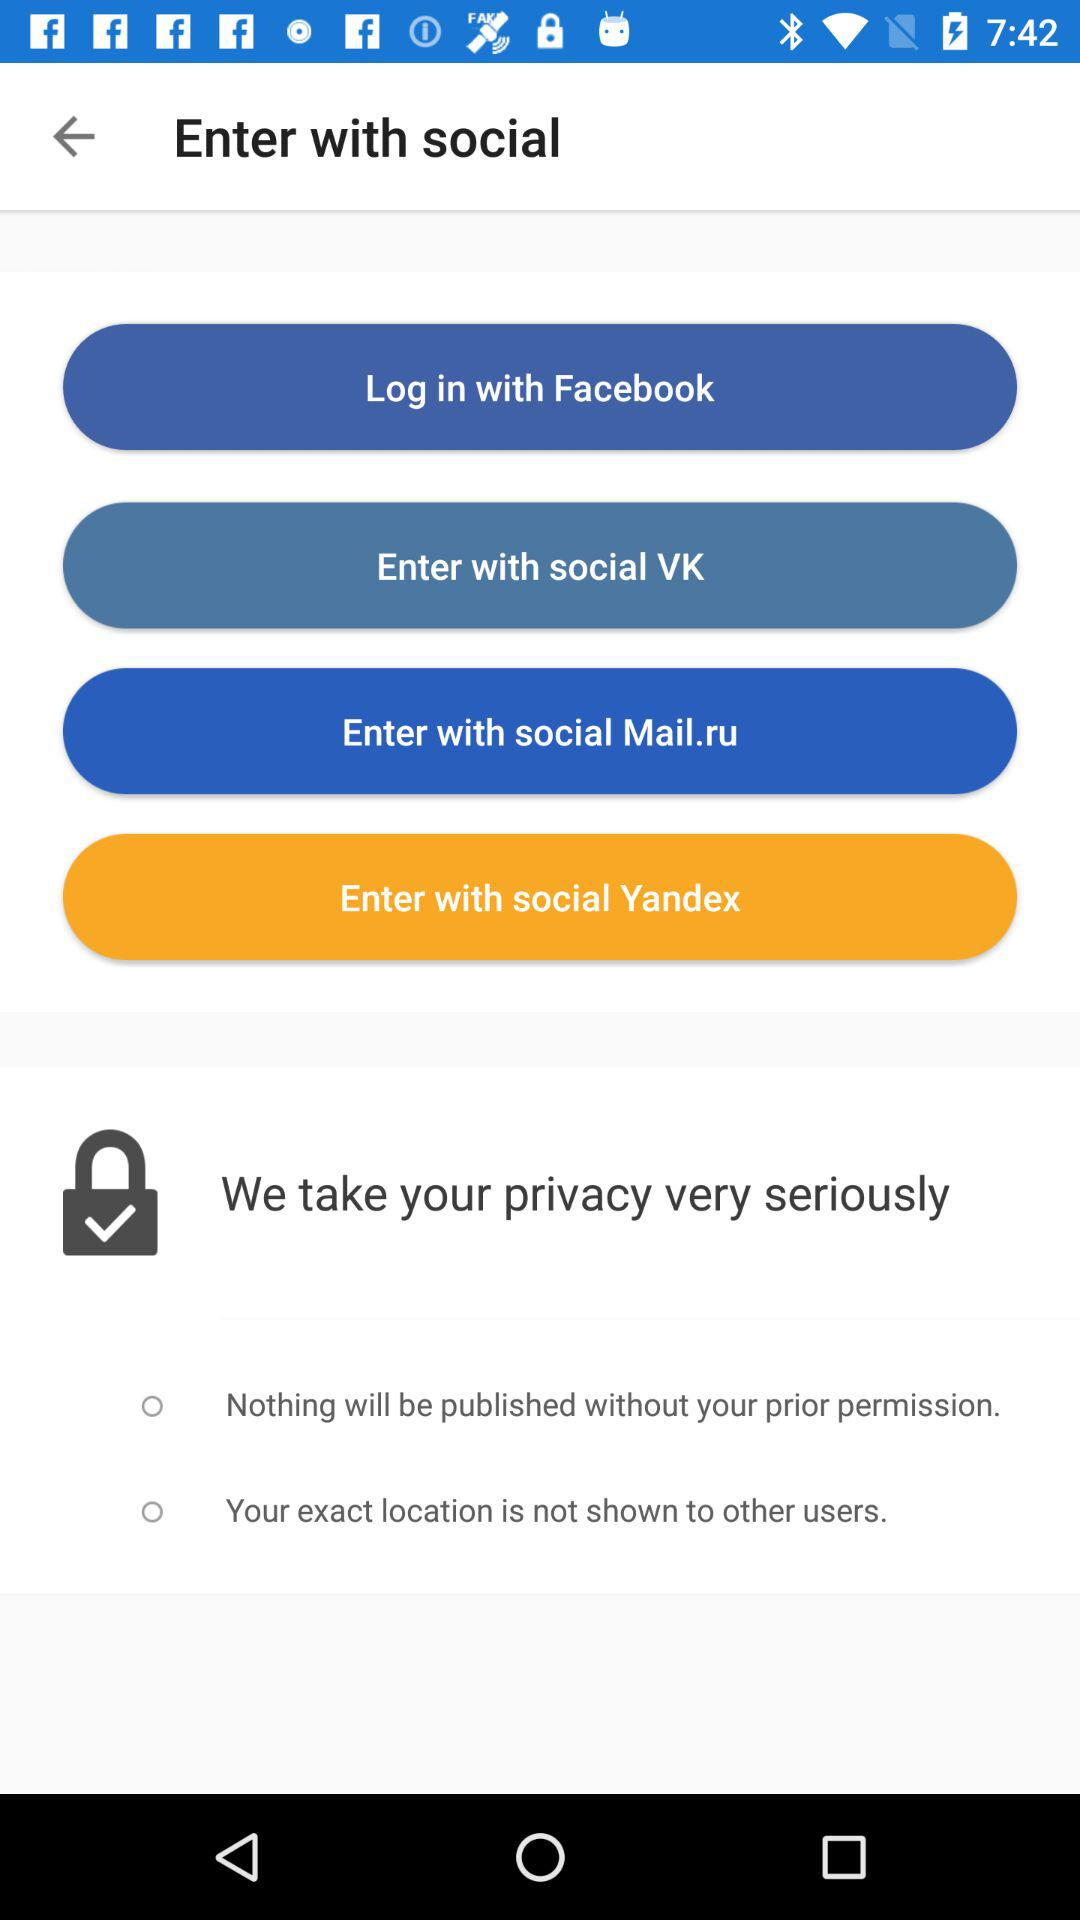How many social media options are there to log in?
Answer the question using a single word or phrase. 4 